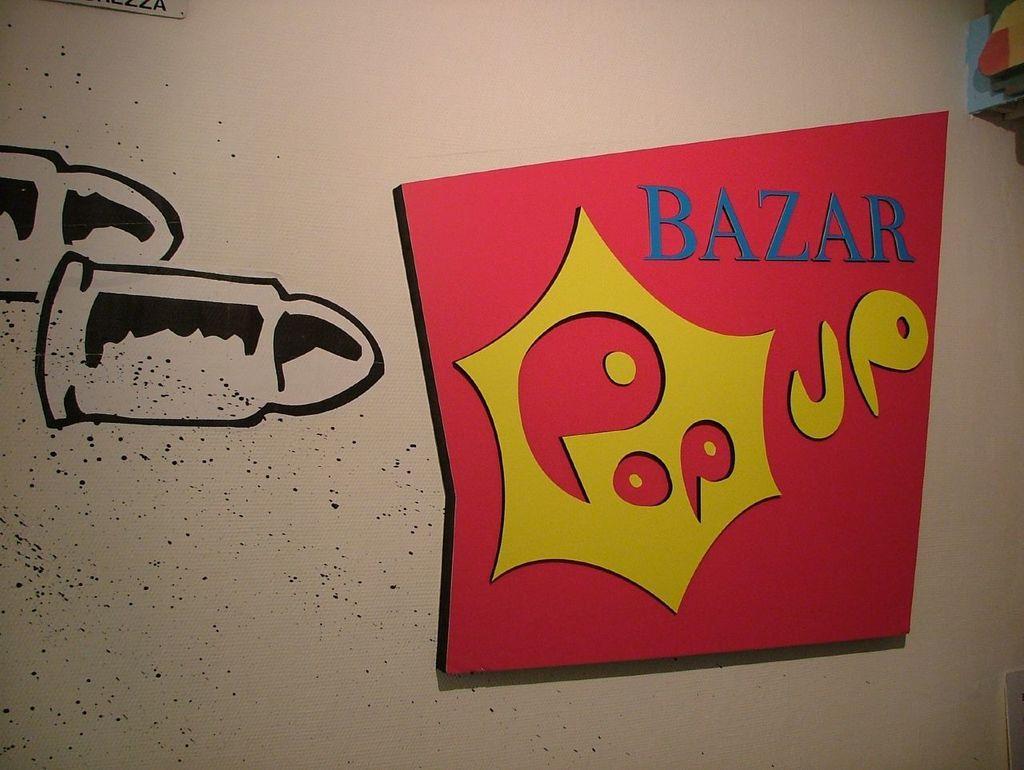How would you summarize this image in a sentence or two? In this picture we can see some painting. 